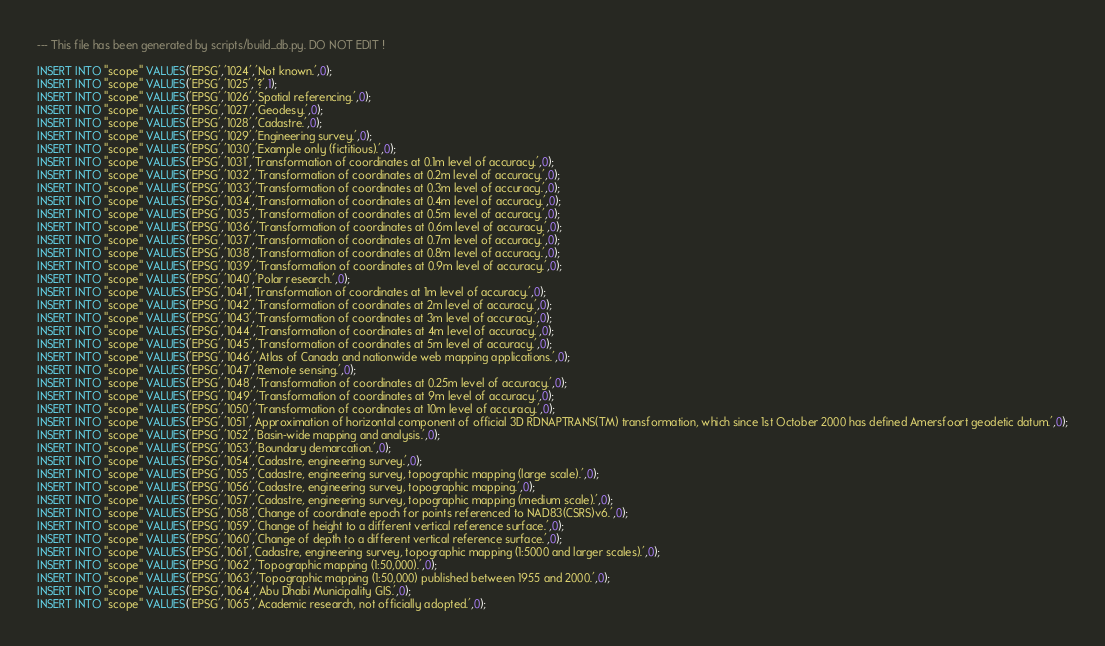<code> <loc_0><loc_0><loc_500><loc_500><_SQL_>--- This file has been generated by scripts/build_db.py. DO NOT EDIT !

INSERT INTO "scope" VALUES('EPSG','1024','Not known.',0);
INSERT INTO "scope" VALUES('EPSG','1025','?',1);
INSERT INTO "scope" VALUES('EPSG','1026','Spatial referencing.',0);
INSERT INTO "scope" VALUES('EPSG','1027','Geodesy.',0);
INSERT INTO "scope" VALUES('EPSG','1028','Cadastre.',0);
INSERT INTO "scope" VALUES('EPSG','1029','Engineering survey.',0);
INSERT INTO "scope" VALUES('EPSG','1030','Example only (fictitious).',0);
INSERT INTO "scope" VALUES('EPSG','1031','Transformation of coordinates at 0.1m level of accuracy.',0);
INSERT INTO "scope" VALUES('EPSG','1032','Transformation of coordinates at 0.2m level of accuracy.',0);
INSERT INTO "scope" VALUES('EPSG','1033','Transformation of coordinates at 0.3m level of accuracy.',0);
INSERT INTO "scope" VALUES('EPSG','1034','Transformation of coordinates at 0.4m level of accuracy.',0);
INSERT INTO "scope" VALUES('EPSG','1035','Transformation of coordinates at 0.5m level of accuracy.',0);
INSERT INTO "scope" VALUES('EPSG','1036','Transformation of coordinates at 0.6m level of accuracy.',0);
INSERT INTO "scope" VALUES('EPSG','1037','Transformation of coordinates at 0.7m level of accuracy.',0);
INSERT INTO "scope" VALUES('EPSG','1038','Transformation of coordinates at 0.8m level of accuracy.',0);
INSERT INTO "scope" VALUES('EPSG','1039','Transformation of coordinates at 0.9m level of accuracy.',0);
INSERT INTO "scope" VALUES('EPSG','1040','Polar research.',0);
INSERT INTO "scope" VALUES('EPSG','1041','Transformation of coordinates at 1m level of accuracy.',0);
INSERT INTO "scope" VALUES('EPSG','1042','Transformation of coordinates at 2m level of accuracy.',0);
INSERT INTO "scope" VALUES('EPSG','1043','Transformation of coordinates at 3m level of accuracy.',0);
INSERT INTO "scope" VALUES('EPSG','1044','Transformation of coordinates at 4m level of accuracy.',0);
INSERT INTO "scope" VALUES('EPSG','1045','Transformation of coordinates at 5m level of accuracy.',0);
INSERT INTO "scope" VALUES('EPSG','1046','Atlas of Canada and nationwide web mapping applications.',0);
INSERT INTO "scope" VALUES('EPSG','1047','Remote sensing.',0);
INSERT INTO "scope" VALUES('EPSG','1048','Transformation of coordinates at 0.25m level of accuracy.',0);
INSERT INTO "scope" VALUES('EPSG','1049','Transformation of coordinates at 9m level of accuracy.',0);
INSERT INTO "scope" VALUES('EPSG','1050','Transformation of coordinates at 10m level of accuracy.',0);
INSERT INTO "scope" VALUES('EPSG','1051','Approximation of horizontal component of official 3D RDNAPTRANS(TM) transformation, which since 1st October 2000 has defined Amersfoort geodetic datum.',0);
INSERT INTO "scope" VALUES('EPSG','1052','Basin-wide mapping and analysis.',0);
INSERT INTO "scope" VALUES('EPSG','1053','Boundary demarcation.',0);
INSERT INTO "scope" VALUES('EPSG','1054','Cadastre, engineering survey.',0);
INSERT INTO "scope" VALUES('EPSG','1055','Cadastre, engineering survey, topographic mapping (large scale).',0);
INSERT INTO "scope" VALUES('EPSG','1056','Cadastre, engineering survey, topographic mapping.',0);
INSERT INTO "scope" VALUES('EPSG','1057','Cadastre, engineering survey, topographic mapping (medium scale).',0);
INSERT INTO "scope" VALUES('EPSG','1058','Change of coordinate epoch for points referenced to NAD83(CSRS)v6.',0);
INSERT INTO "scope" VALUES('EPSG','1059','Change of height to a different vertical reference surface.',0);
INSERT INTO "scope" VALUES('EPSG','1060','Change of depth to a different vertical reference surface.',0);
INSERT INTO "scope" VALUES('EPSG','1061','Cadastre, engineering survey, topographic mapping (1:5000 and larger scales).',0);
INSERT INTO "scope" VALUES('EPSG','1062','Topographic mapping (1:50,000).',0);
INSERT INTO "scope" VALUES('EPSG','1063','Topographic mapping (1:50,000) published between 1955 and 2000.',0);
INSERT INTO "scope" VALUES('EPSG','1064','Abu Dhabi Municipality GIS.',0);
INSERT INTO "scope" VALUES('EPSG','1065','Academic research, not officially adopted.',0);</code> 